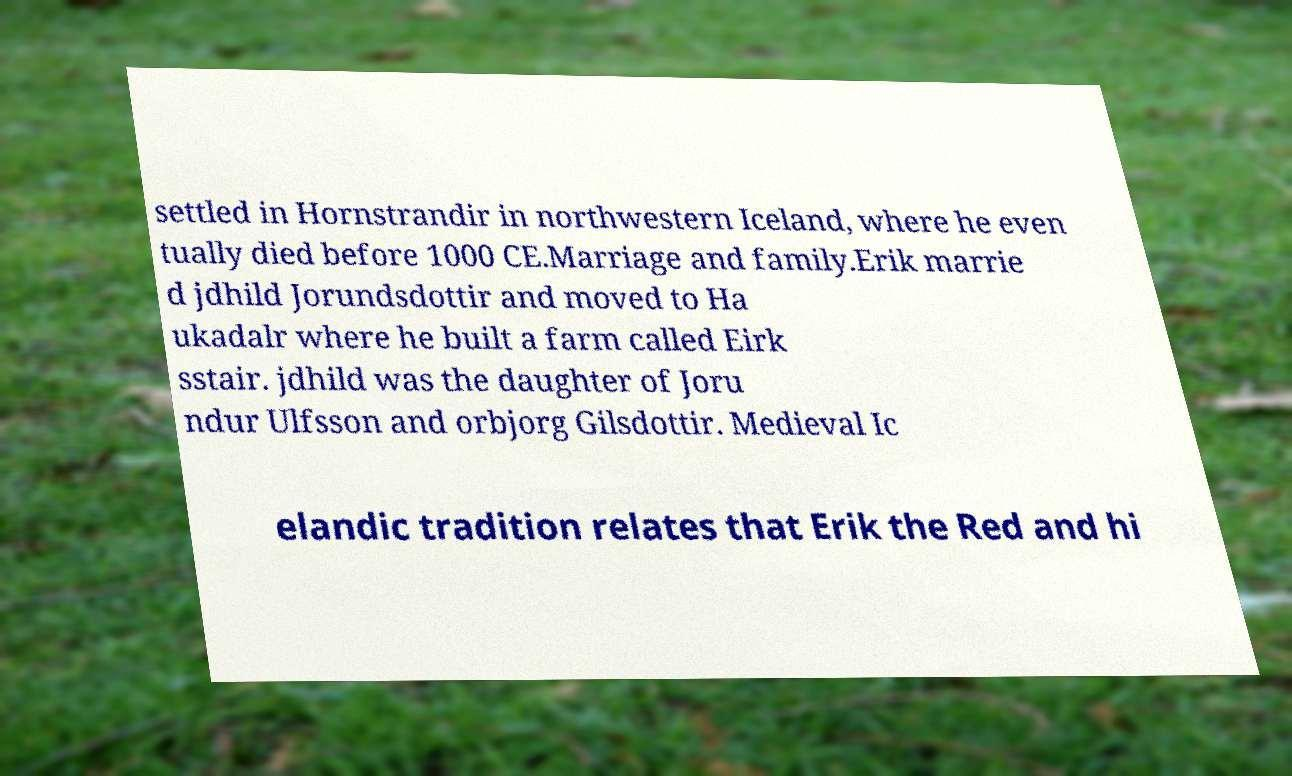Please identify and transcribe the text found in this image. settled in Hornstrandir in northwestern Iceland, where he even tually died before 1000 CE.Marriage and family.Erik marrie d jdhild Jorundsdottir and moved to Ha ukadalr where he built a farm called Eirk sstair. jdhild was the daughter of Joru ndur Ulfsson and orbjorg Gilsdottir. Medieval Ic elandic tradition relates that Erik the Red and hi 